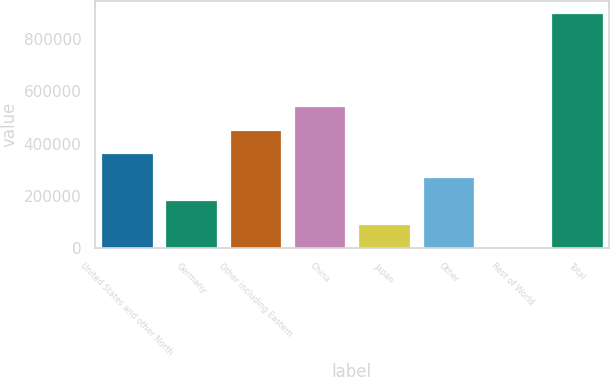<chart> <loc_0><loc_0><loc_500><loc_500><bar_chart><fcel>United States and other North<fcel>Germany<fcel>Other including Eastern<fcel>China<fcel>Japan<fcel>Other<fcel>Rest of World<fcel>Total<nl><fcel>362511<fcel>182927<fcel>452304<fcel>542096<fcel>93134.3<fcel>272719<fcel>3342<fcel>901265<nl></chart> 